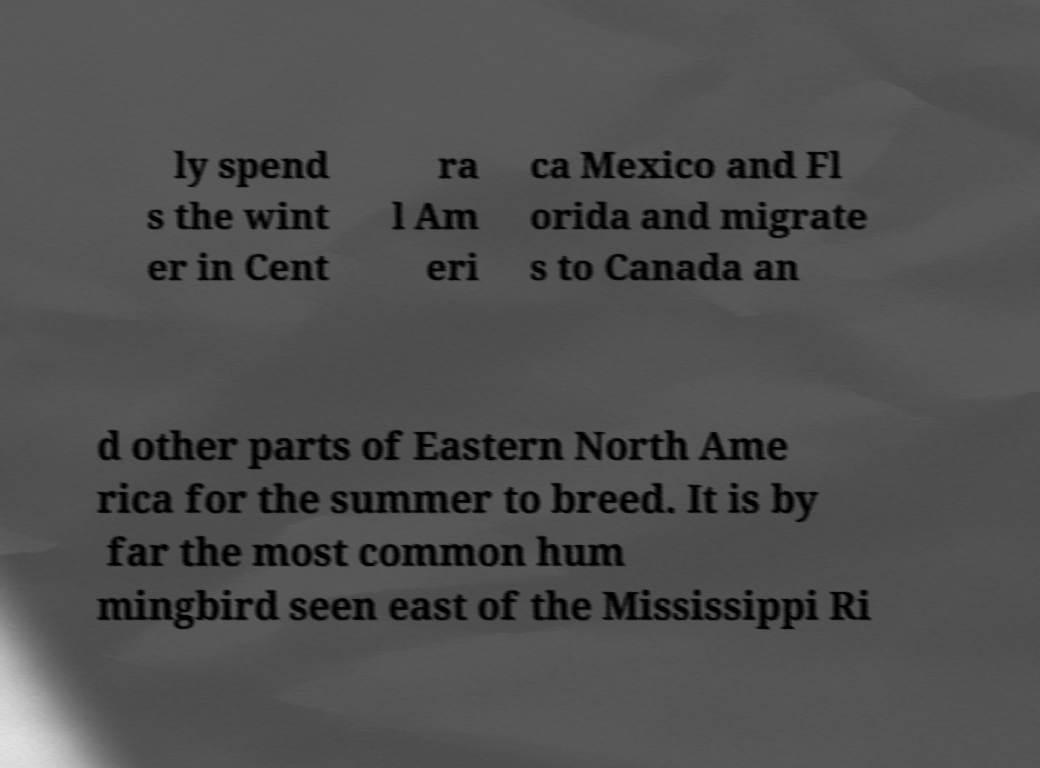I need the written content from this picture converted into text. Can you do that? ly spend s the wint er in Cent ra l Am eri ca Mexico and Fl orida and migrate s to Canada an d other parts of Eastern North Ame rica for the summer to breed. It is by far the most common hum mingbird seen east of the Mississippi Ri 